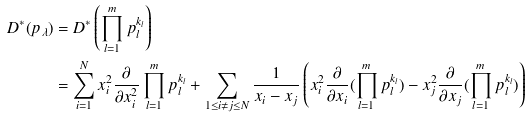Convert formula to latex. <formula><loc_0><loc_0><loc_500><loc_500>D ^ { \ast } ( p _ { \lambda } ) & = D ^ { * } \left ( \prod _ { l = 1 } ^ { m } p _ { l } ^ { k _ { l } } \right ) \\ & = \sum _ { i = 1 } ^ { N } x _ { i } ^ { 2 } \frac { \partial } { \partial x _ { i } ^ { 2 } } \prod _ { l = 1 } ^ { m } p _ { l } ^ { k _ { l } } + \sum _ { 1 \leq i \neq j \leq N } \frac { 1 } { x _ { i } - x _ { j } } \left ( x _ { i } ^ { 2 } \frac { \partial } { \partial x _ { i } } ( \prod _ { l = 1 } ^ { m } p _ { l } ^ { k _ { l } } ) - x _ { j } ^ { 2 } \frac { \partial } { \partial x _ { j } } ( \prod _ { l = 1 } ^ { m } p _ { l } ^ { k _ { l } } ) \right )</formula> 